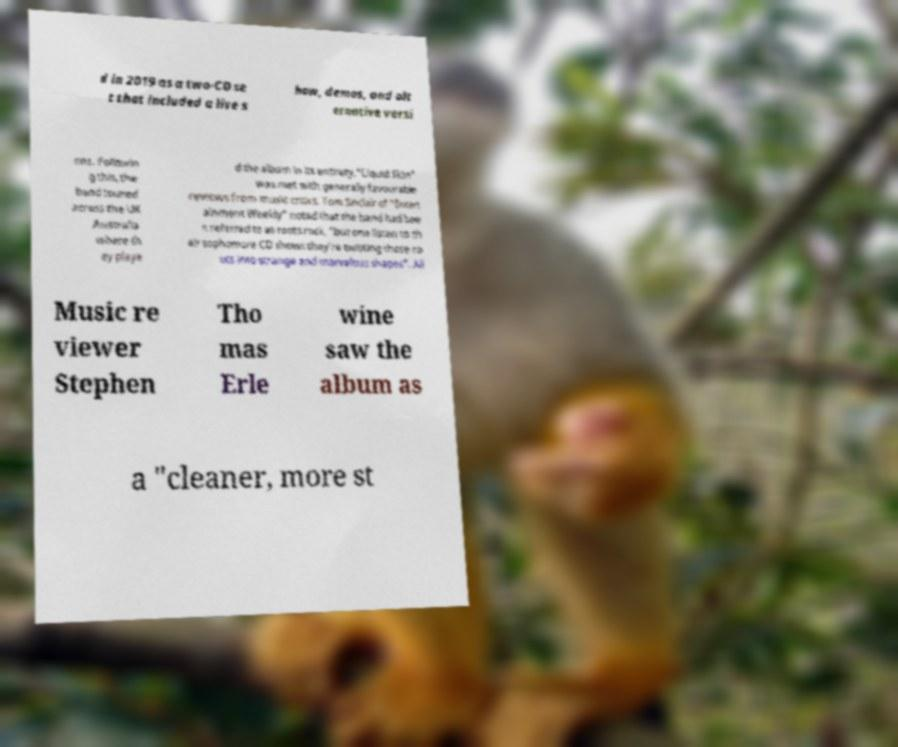Please read and relay the text visible in this image. What does it say? d in 2019 as a two-CD se t that included a live s how, demos, and alt ernative versi ons. Followin g this, the band toured across the UK Australia where th ey playe d the album in its entirety."Liquid Skin" was met with generally favourable reviews from music critics. Tom Sinclair of "Entert ainment Weekly" noted that the band had bee n referred to as roots rock, "but one listen to th eir sophomore CD shows they’re twisting those ro ots into strange and marvelous shapes". All Music re viewer Stephen Tho mas Erle wine saw the album as a "cleaner, more st 